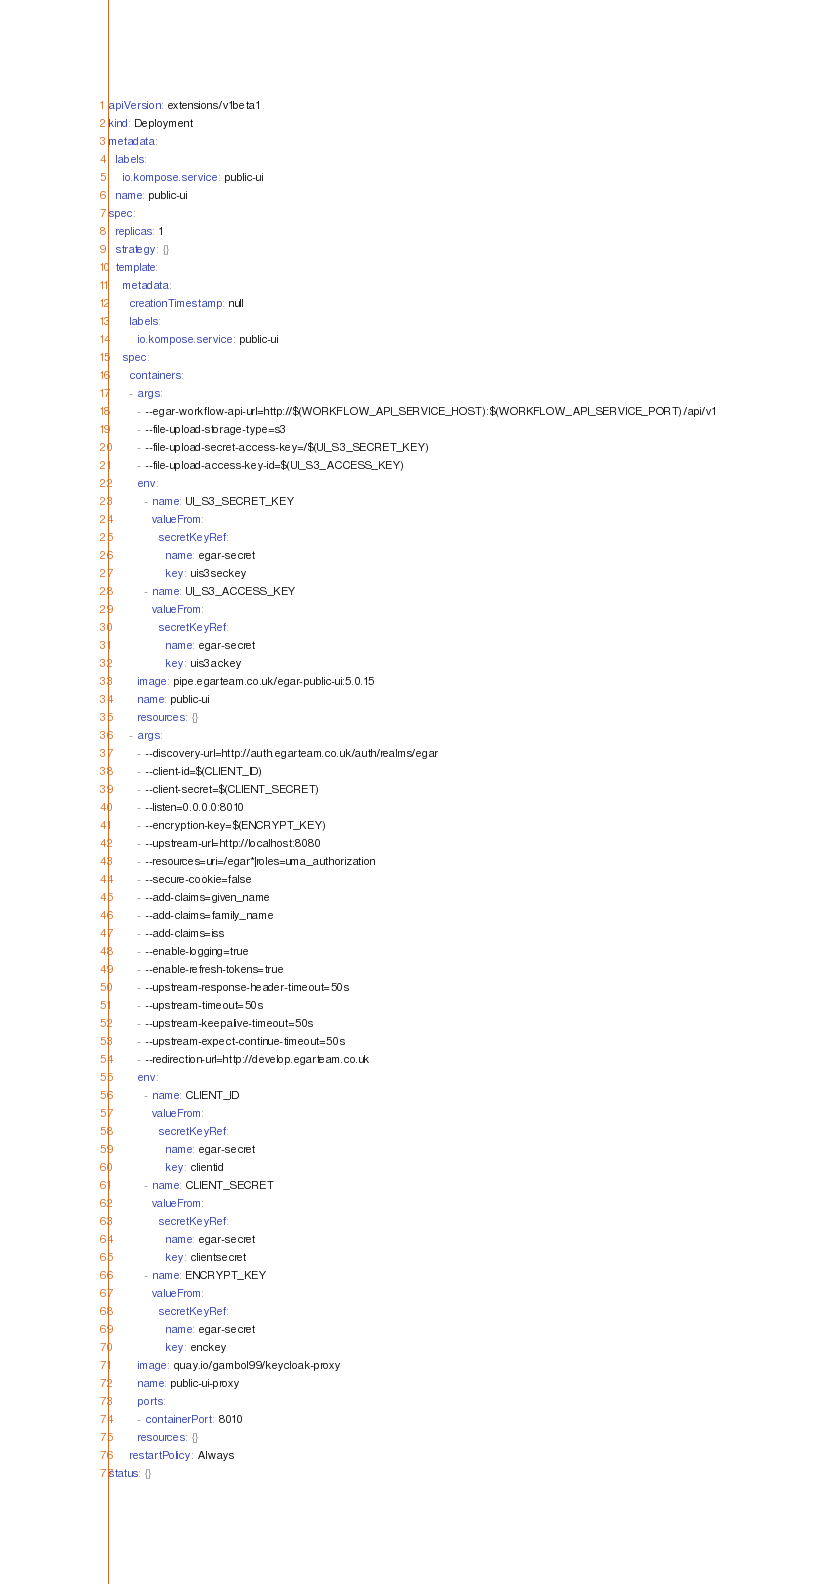Convert code to text. <code><loc_0><loc_0><loc_500><loc_500><_YAML_>apiVersion: extensions/v1beta1
kind: Deployment
metadata:
  labels:
    io.kompose.service: public-ui
  name: public-ui
spec:
  replicas: 1
  strategy: {}
  template:
    metadata:
      creationTimestamp: null
      labels:
        io.kompose.service: public-ui
    spec:
      containers:
      - args:
        - --egar-workflow-api-url=http://$(WORKFLOW_API_SERVICE_HOST):$(WORKFLOW_API_SERVICE_PORT)/api/v1
        - --file-upload-storage-type=s3
        - --file-upload-secret-access-key=/$(UI_S3_SECRET_KEY)
        - --file-upload-access-key-id=$(UI_S3_ACCESS_KEY)
        env:
          - name: UI_S3_SECRET_KEY
            valueFrom:
              secretKeyRef:
                name: egar-secret
                key: uis3seckey
          - name: UI_S3_ACCESS_KEY
            valueFrom:
              secretKeyRef:
                name: egar-secret
                key: uis3ackey
        image: pipe.egarteam.co.uk/egar-public-ui:5.0.15
        name: public-ui
        resources: {}
      - args:
        - --discovery-url=http://auth.egarteam.co.uk/auth/realms/egar
        - --client-id=$(CLIENT_ID)
        - --client-secret=$(CLIENT_SECRET)
        - --listen=0.0.0.0:8010
        - --encryption-key=$(ENCRYPT_KEY)
        - --upstream-url=http://localhost:8080
        - --resources=uri=/egar*|roles=uma_authorization
        - --secure-cookie=false
        - --add-claims=given_name
        - --add-claims=family_name
        - --add-claims=iss
        - --enable-logging=true
        - --enable-refresh-tokens=true
        - --upstream-response-header-timeout=50s
        - --upstream-timeout=50s
        - --upstream-keepalive-timeout=50s
        - --upstream-expect-continue-timeout=50s
        - --redirection-url=http://develop.egarteam.co.uk
        env:
          - name: CLIENT_ID
            valueFrom:
              secretKeyRef:
                name: egar-secret
                key: clientid
          - name: CLIENT_SECRET
            valueFrom:
              secretKeyRef:
                name: egar-secret
                key: clientsecret
          - name: ENCRYPT_KEY
            valueFrom:
              secretKeyRef:
                name: egar-secret
                key: enckey
        image: quay.io/gambol99/keycloak-proxy
        name: public-ui-proxy
        ports:
        - containerPort: 8010
        resources: {}
      restartPolicy: Always
status: {}

</code> 